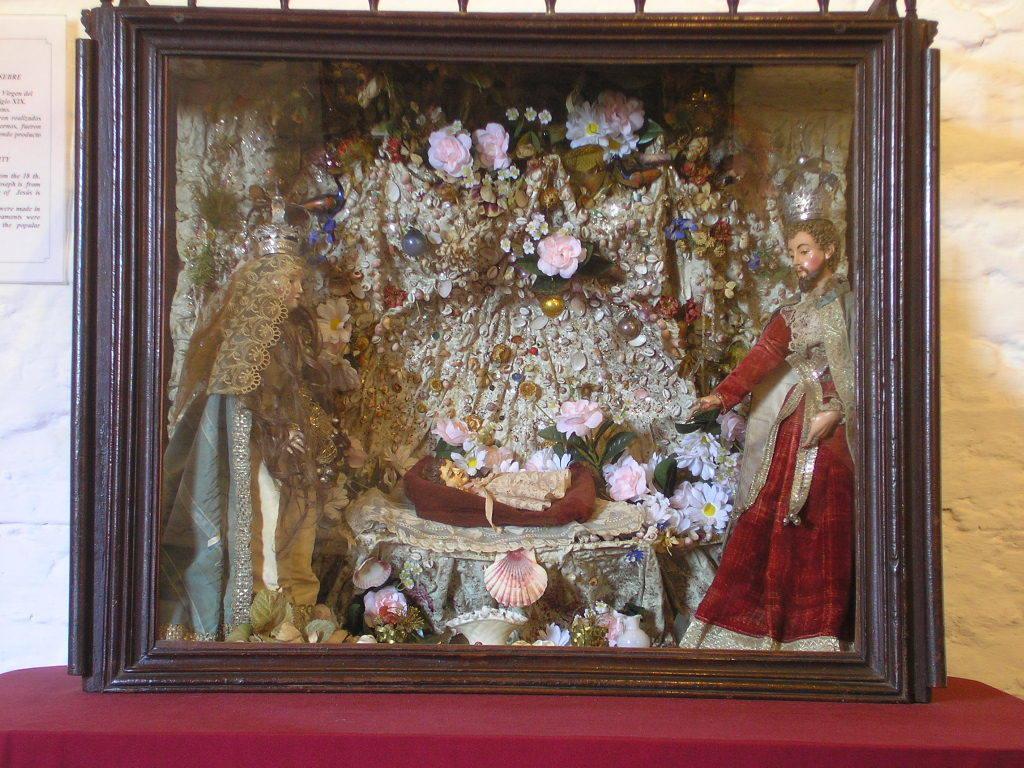In one or two sentences, can you explain what this image depicts? In this picture we can see a photo frame on a platform, on this frame we can see statue of people, flowers and some objects and in the background we can see a wall, poster. 